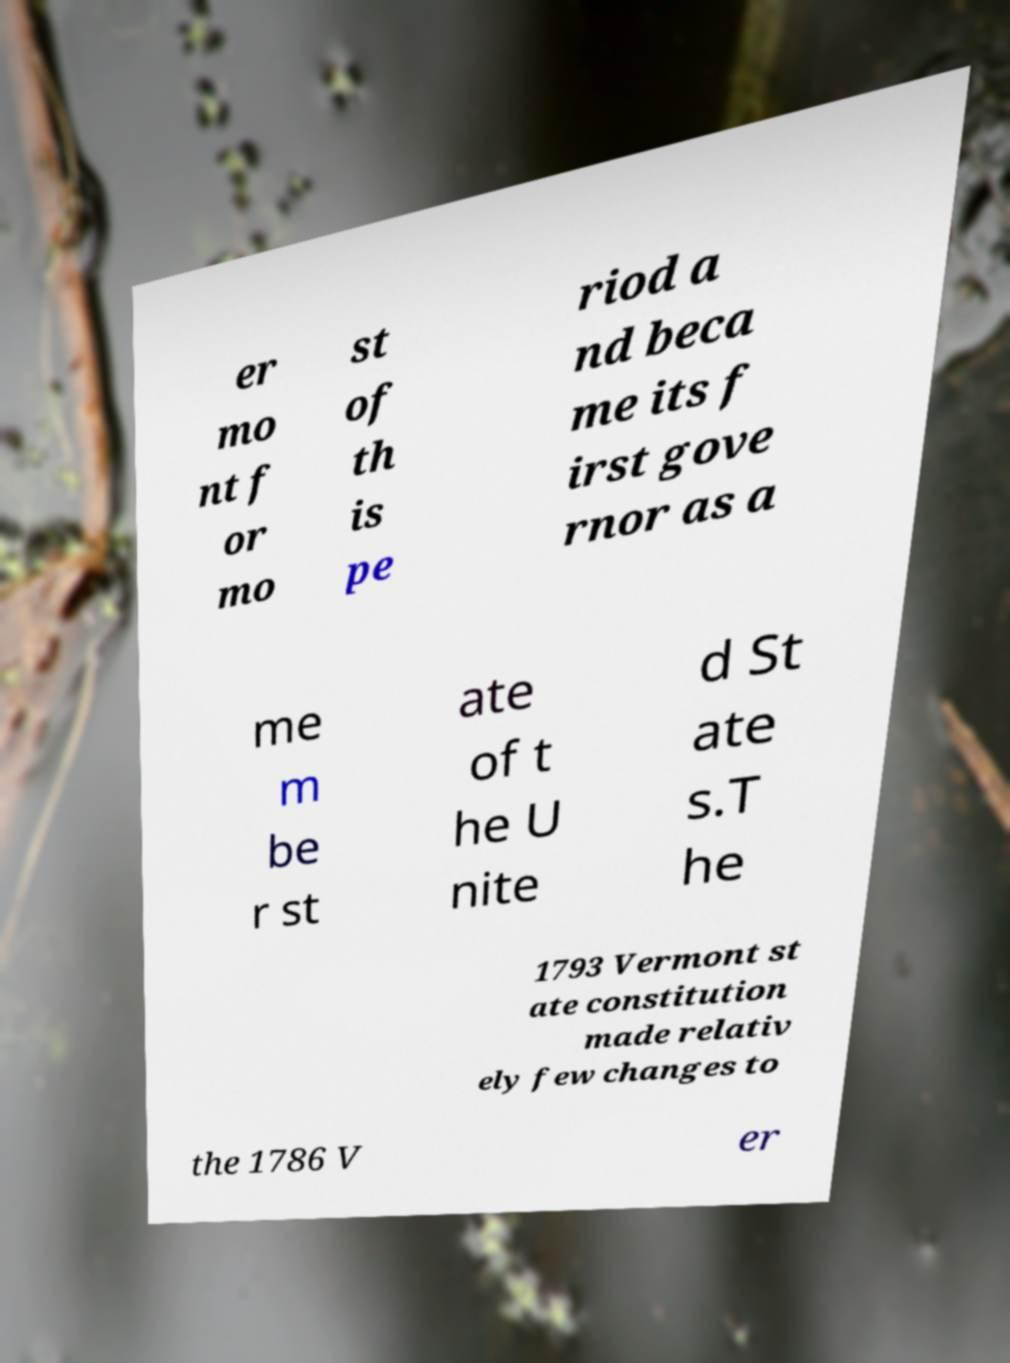I need the written content from this picture converted into text. Can you do that? er mo nt f or mo st of th is pe riod a nd beca me its f irst gove rnor as a me m be r st ate of t he U nite d St ate s.T he 1793 Vermont st ate constitution made relativ ely few changes to the 1786 V er 